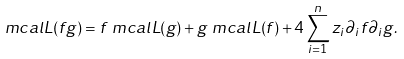Convert formula to latex. <formula><loc_0><loc_0><loc_500><loc_500>\ m c a l { L } ( f g ) & = f \ m c a l { L } ( g ) + g \ m c a l { L } ( f ) + 4 \sum _ { i = 1 } ^ { n } z _ { i } \partial _ { i } f \partial _ { i } g .</formula> 